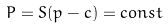Convert formula to latex. <formula><loc_0><loc_0><loc_500><loc_500>& P = S ( p - c ) = c o n s t</formula> 